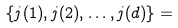Convert formula to latex. <formula><loc_0><loc_0><loc_500><loc_500>\{ j ( 1 ) , j ( 2 ) , \dots , j ( d ) \} =</formula> 